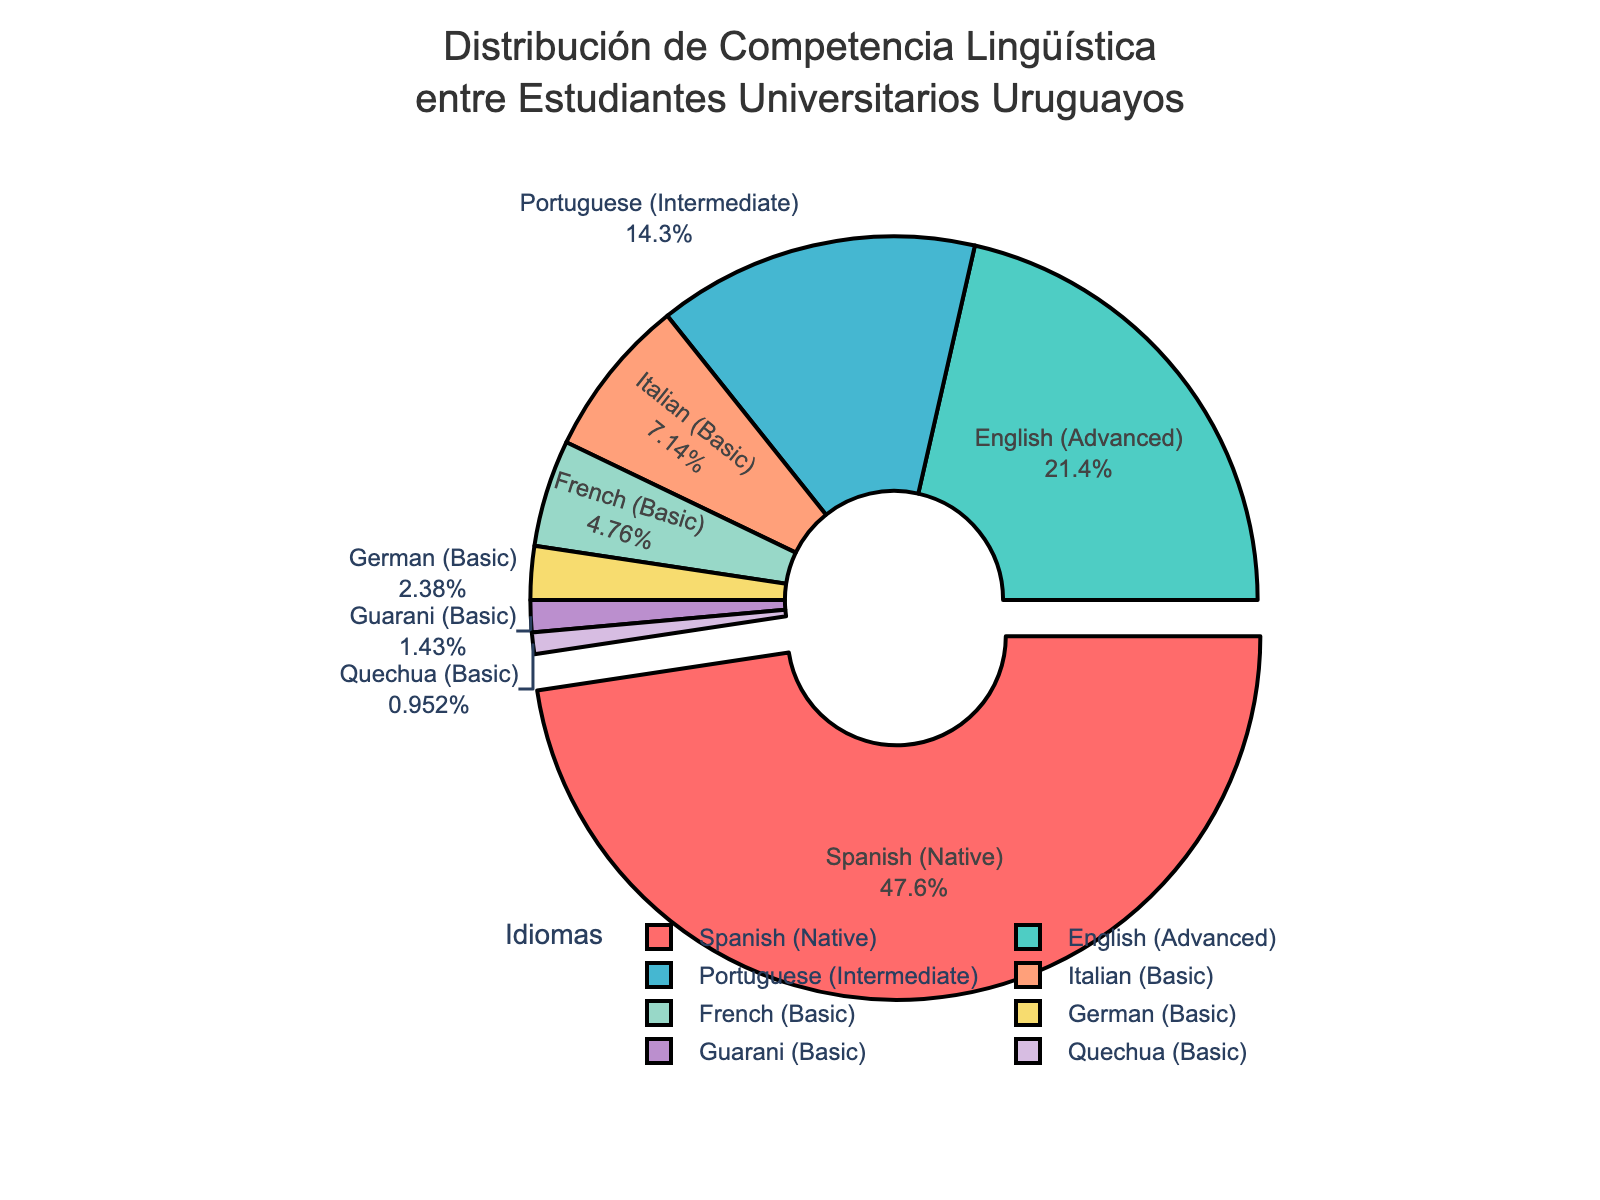What percentage of Uruguayan university students have advanced proficiency in English? The pie chart shows the percentage of students with advanced proficiency in English as one of the segments. The value indicated is 45%.
Answer: 45% Which language has the second highest percentage after Spanish (Native)? The pie chart indicates various percentages for language proficiency levels. Spanish (Native) is 100%, and the next highest percentage is for English (Advanced) at 45%.
Answer: English What is the sum of the percentages of students with basic proficiency in languages? Summing up the percentages for basic proficiency (Italian - 15%, French - 10%, German - 5%, Guarani - 3%, Quechua - 2%) gives 15% + 10% + 5% + 3% + 2% = 35%.
Answer: 35% Which languages have lower proficiency percentages than Italian (Basic)? The pie chart shows Italian (Basic) at 15%. Languages with lower percentages are French (10%), German (5%), Guarani (3%), and Quechua (2%).
Answer: French, German, Guarani, Quechua What percentage of students have either intermediate or basic proficiency in Portuguese or Italian? The pie chart shows Portuguese at 30% (Intermediate) and Italian at 15% (Basic). The sum is 30% + 15% = 45%.
Answer: 45% How many languages have a proficiency percentage below 10%? The pie chart shows German (5%), Guarani (3%), and Quechua (2%), all below 10%. There are 3 such languages.
Answer: 3 Which language proficiency is visually emphasized compared to others? The pie chart visually differentiates languages by pulling out the section with the highest percentage. Spanish (Native) is emphasized.
Answer: Spanish (Native) What is the combined percentage of students with advanced proficiency in English and intermediate proficiency in Portuguese? The pie chart shows English at 45% (Advanced) and Portuguese at 30% (Intermediate). The combined percentage is 45% + 30% = 75%.
Answer: 75% Compare the percentages of students with basic proficiency in French and Italian. Which is higher and by how much? The pie chart shows basic proficiency in French at 10% and in Italian at 15%. The difference is 15% - 10% = 5%.
Answer: Italian by 5% What color represents students with intermediate proficiency in Portuguese? Visual attributes of the pie chart indicate that the section for intermediate proficiency in Portuguese is colored in a specific shade, identified as turquoise.
Answer: Turquoise 